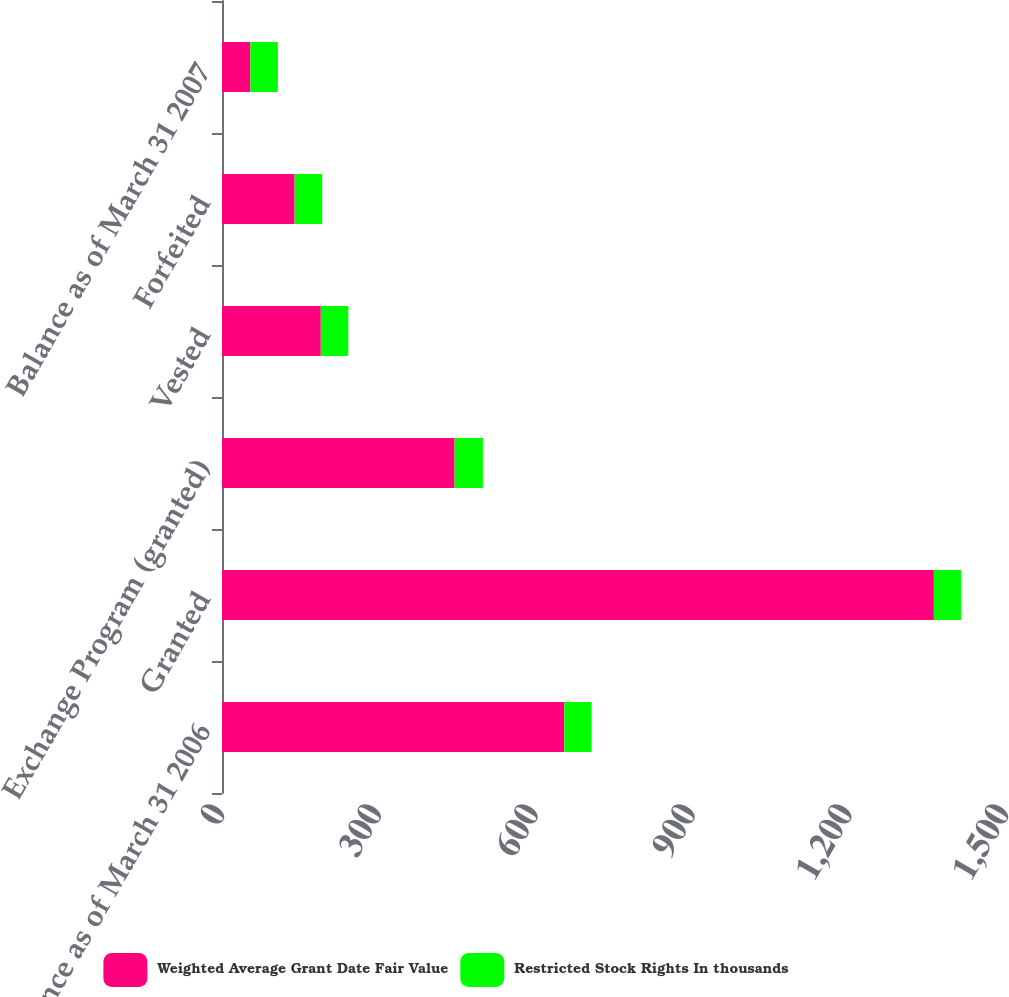<chart> <loc_0><loc_0><loc_500><loc_500><stacked_bar_chart><ecel><fcel>Balance as of March 31 2006<fcel>Granted<fcel>Exchange Program (granted)<fcel>Vested<fcel>Forfeited<fcel>Balance as of March 31 2007<nl><fcel>Weighted Average Grant Date Fair Value<fcel>655<fcel>1362<fcel>445<fcel>189<fcel>139<fcel>54.22<nl><fcel>Restricted Stock Rights In thousands<fcel>52.21<fcel>52.31<fcel>54.22<fcel>52.6<fcel>52.74<fcel>52.62<nl></chart> 